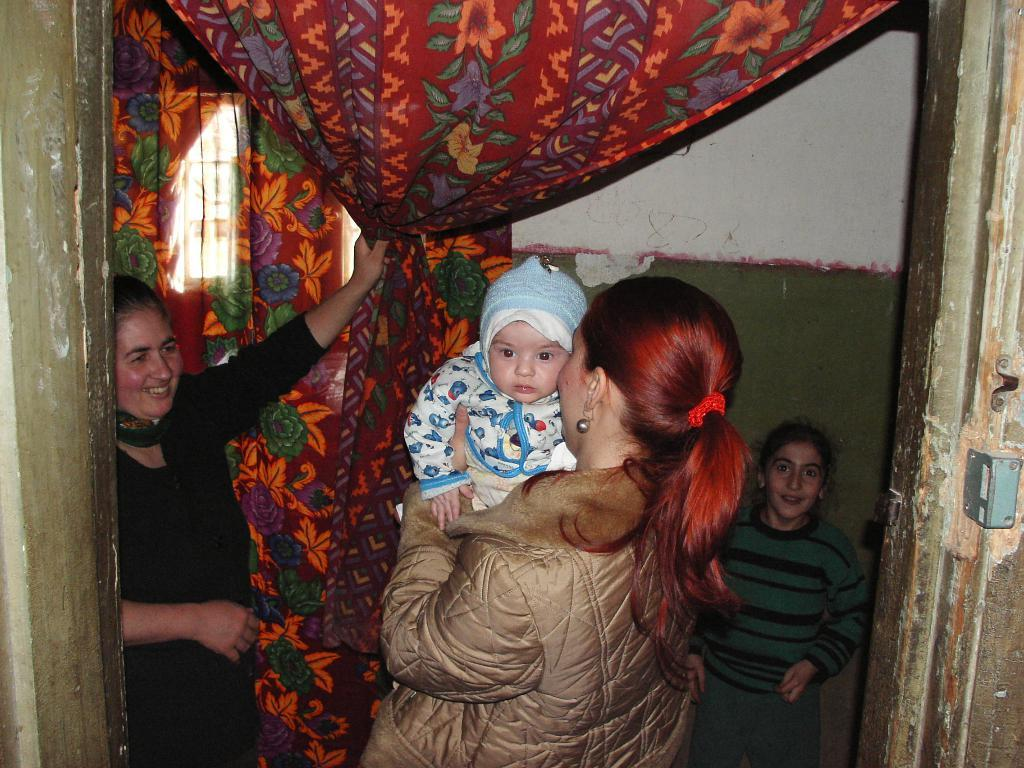What are the people in the image wearing? The people in the image are wearing coats. Can you describe the lady in the image? The lady in the image is holding a baby. What can be seen in the background of the image? There are curtains, a wall, and a window in the background of the image. What type of feather can be seen on the floor in the image? There is no feather present on the floor in the image. Can you describe the vase on the table in the image? There is no vase present on a table in the image. 